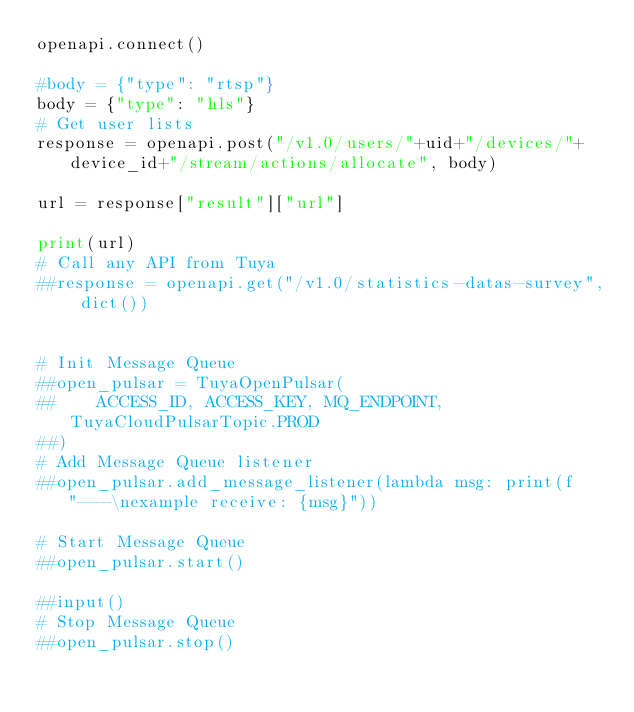<code> <loc_0><loc_0><loc_500><loc_500><_Python_>openapi.connect()

#body = {"type": "rtsp"}
body = {"type": "hls"}
# Get user lists
response = openapi.post("/v1.0/users/"+uid+"/devices/"+device_id+"/stream/actions/allocate", body)

url = response["result"]["url"]

print(url)
# Call any API from Tuya
##response = openapi.get("/v1.0/statistics-datas-survey", dict())


# Init Message Queue
##open_pulsar = TuyaOpenPulsar(
##    ACCESS_ID, ACCESS_KEY, MQ_ENDPOINT, TuyaCloudPulsarTopic.PROD
##)
# Add Message Queue listener
##open_pulsar.add_message_listener(lambda msg: print(f"---\nexample receive: {msg}"))

# Start Message Queue
##open_pulsar.start()

##input()
# Stop Message Queue
##open_pulsar.stop()

</code> 